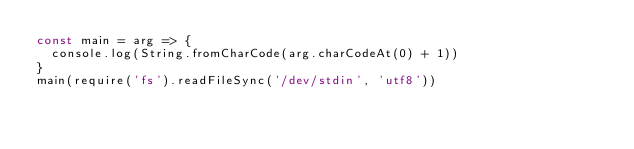<code> <loc_0><loc_0><loc_500><loc_500><_JavaScript_>const main = arg => {
  console.log(String.fromCharCode(arg.charCodeAt(0) + 1))
}
main(require('fs').readFileSync('/dev/stdin', 'utf8'))</code> 